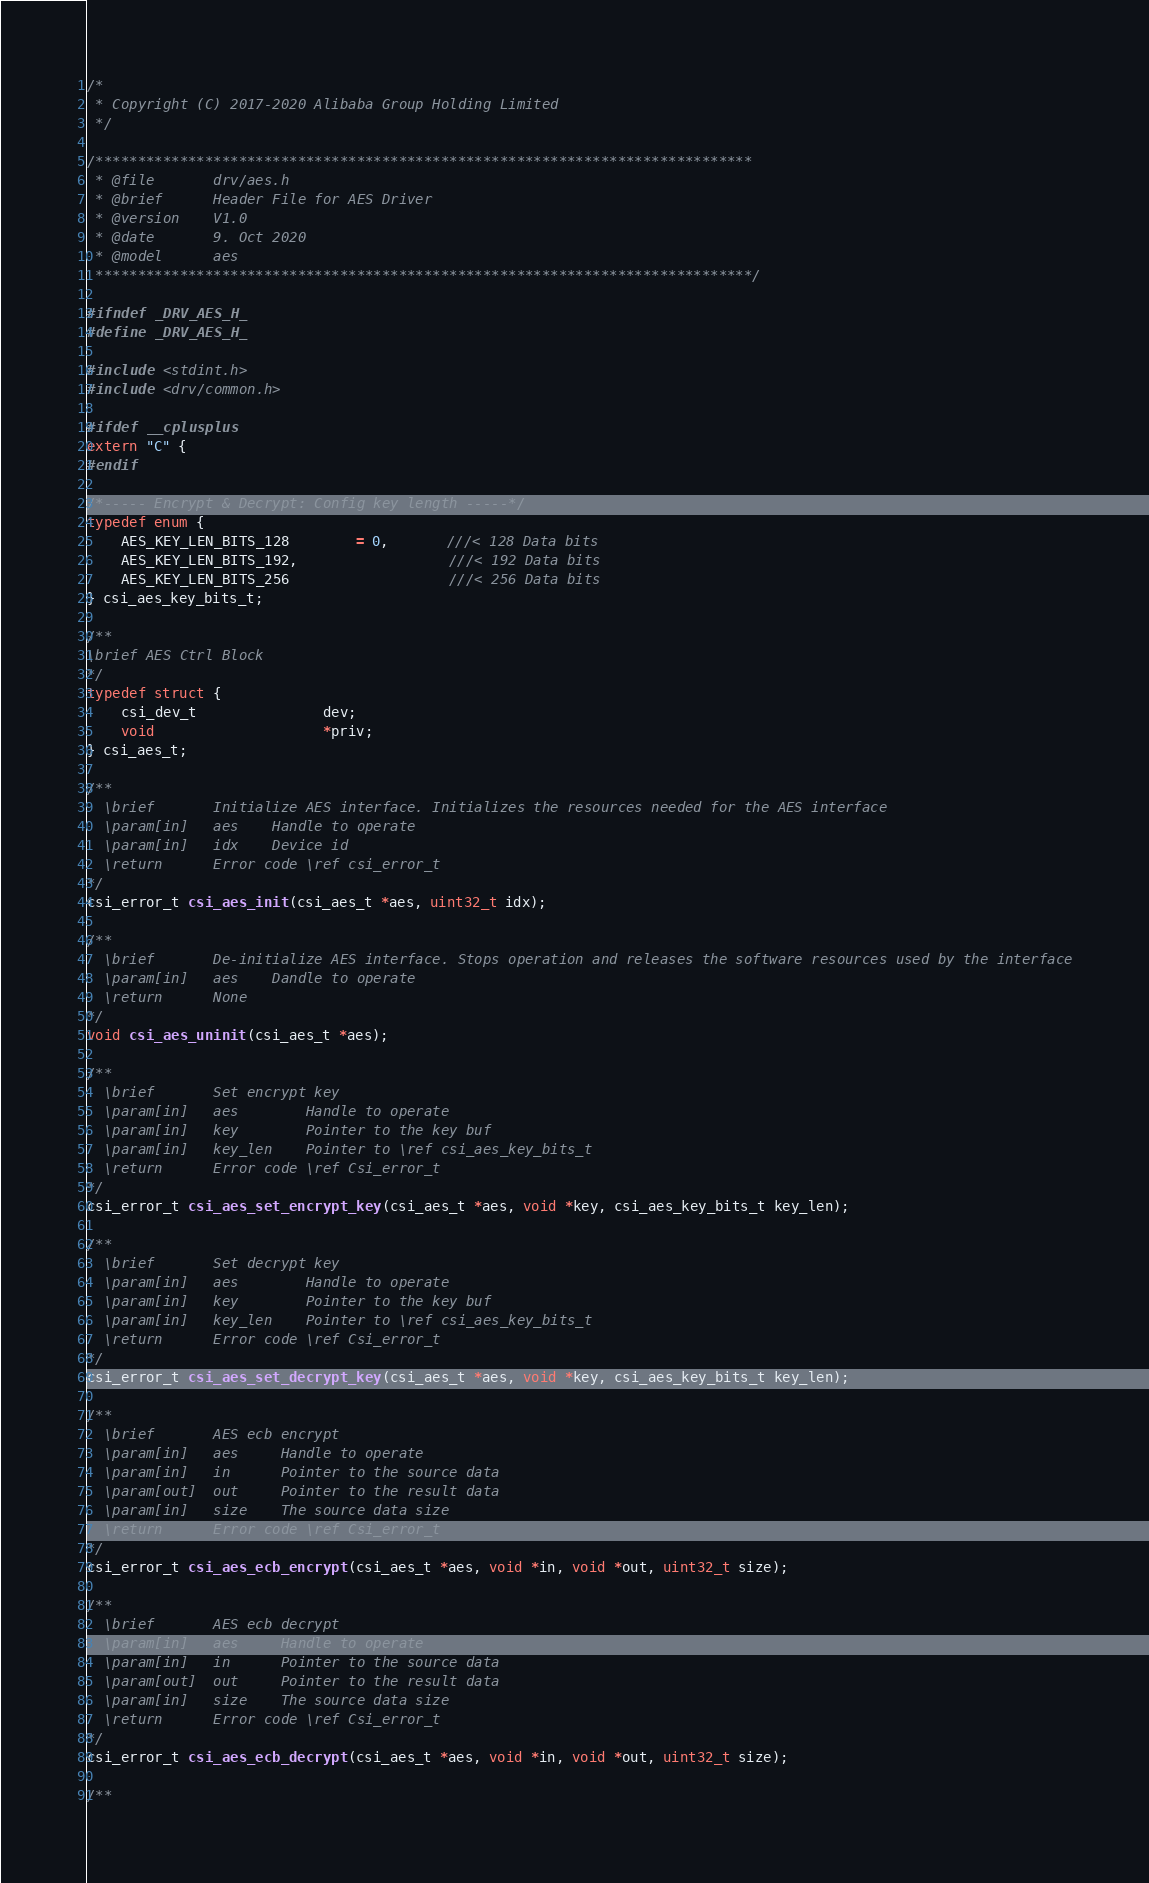<code> <loc_0><loc_0><loc_500><loc_500><_C_>/*
 * Copyright (C) 2017-2020 Alibaba Group Holding Limited
 */

/******************************************************************************
 * @file       drv/aes.h
 * @brief      Header File for AES Driver
 * @version    V1.0
 * @date       9. Oct 2020
 * @model      aes
 ******************************************************************************/

#ifndef _DRV_AES_H_
#define _DRV_AES_H_

#include <stdint.h>
#include <drv/common.h>

#ifdef __cplusplus
extern "C" {
#endif

/*----- Encrypt & Decrypt: Config key length -----*/
typedef enum {
    AES_KEY_LEN_BITS_128        = 0,       ///< 128 Data bits
    AES_KEY_LEN_BITS_192,                  ///< 192 Data bits
    AES_KEY_LEN_BITS_256                   ///< 256 Data bits
} csi_aes_key_bits_t;

/**
\brief AES Ctrl Block
*/
typedef struct {
    csi_dev_t               dev;
    void                    *priv;
} csi_aes_t;

/**
  \brief       Initialize AES interface. Initializes the resources needed for the AES interface
  \param[in]   aes    Handle to operate
  \param[in]   idx    Device id
  \return      Error code \ref csi_error_t
*/
csi_error_t csi_aes_init(csi_aes_t *aes, uint32_t idx);

/**
  \brief       De-initialize AES interface. Stops operation and releases the software resources used by the interface
  \param[in]   aes    Dandle to operate
  \return      None
*/
void csi_aes_uninit(csi_aes_t *aes);

/**
  \brief       Set encrypt key
  \param[in]   aes        Handle to operate
  \param[in]   key        Pointer to the key buf
  \param[in]   key_len    Pointer to \ref csi_aes_key_bits_t
  \return      Error code \ref Csi_error_t
*/
csi_error_t csi_aes_set_encrypt_key(csi_aes_t *aes, void *key, csi_aes_key_bits_t key_len);

/**
  \brief       Set decrypt key
  \param[in]   aes        Handle to operate
  \param[in]   key        Pointer to the key buf
  \param[in]   key_len    Pointer to \ref csi_aes_key_bits_t
  \return      Error code \ref Csi_error_t
*/
csi_error_t csi_aes_set_decrypt_key(csi_aes_t *aes, void *key, csi_aes_key_bits_t key_len);

/**
  \brief       AES ecb encrypt
  \param[in]   aes     Handle to operate
  \param[in]   in      Pointer to the source data
  \param[out]  out     Pointer to the result data
  \param[in]   size    The source data size
  \return      Error code \ref Csi_error_t
*/
csi_error_t csi_aes_ecb_encrypt(csi_aes_t *aes, void *in, void *out, uint32_t size);

/**
  \brief       AES ecb decrypt
  \param[in]   aes     Handle to operate
  \param[in]   in      Pointer to the source data
  \param[out]  out     Pointer to the result data
  \param[in]   size    The source data size
  \return      Error code \ref Csi_error_t
*/
csi_error_t csi_aes_ecb_decrypt(csi_aes_t *aes, void *in, void *out, uint32_t size);

/**</code> 